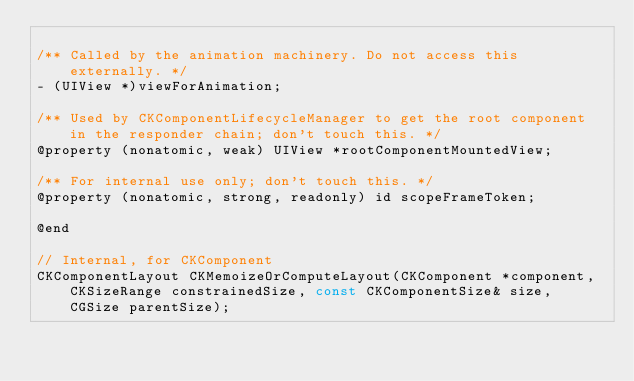Convert code to text. <code><loc_0><loc_0><loc_500><loc_500><_C_>
/** Called by the animation machinery. Do not access this externally. */
- (UIView *)viewForAnimation;

/** Used by CKComponentLifecycleManager to get the root component in the responder chain; don't touch this. */
@property (nonatomic, weak) UIView *rootComponentMountedView;

/** For internal use only; don't touch this. */
@property (nonatomic, strong, readonly) id scopeFrameToken;

@end

// Internal, for CKComponent
CKComponentLayout CKMemoizeOrComputeLayout(CKComponent *component, CKSizeRange constrainedSize, const CKComponentSize& size, CGSize parentSize);
</code> 